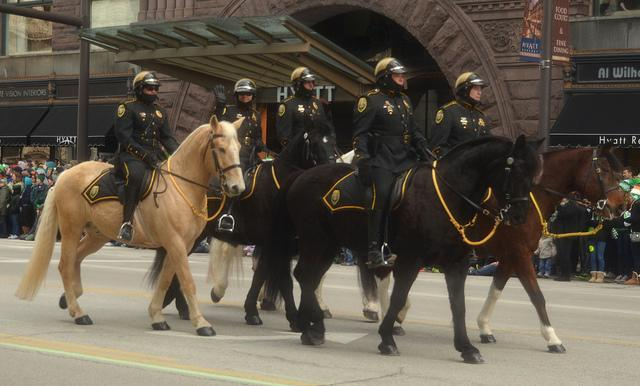What hotel is in the background behind the policemen and horses? Please explain your reasoning. hyatt. You can see some of the letters on the sign. 